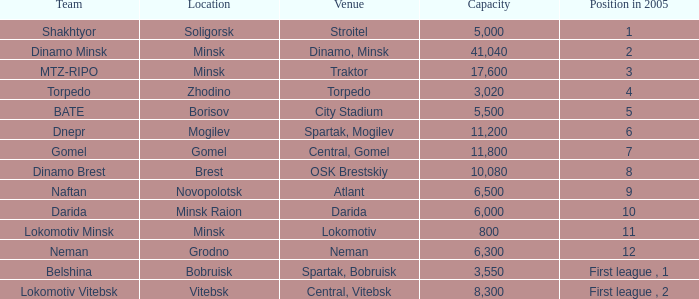Are you able to disclose the site that had the standing in 2005 of 8? OSK Brestskiy. 